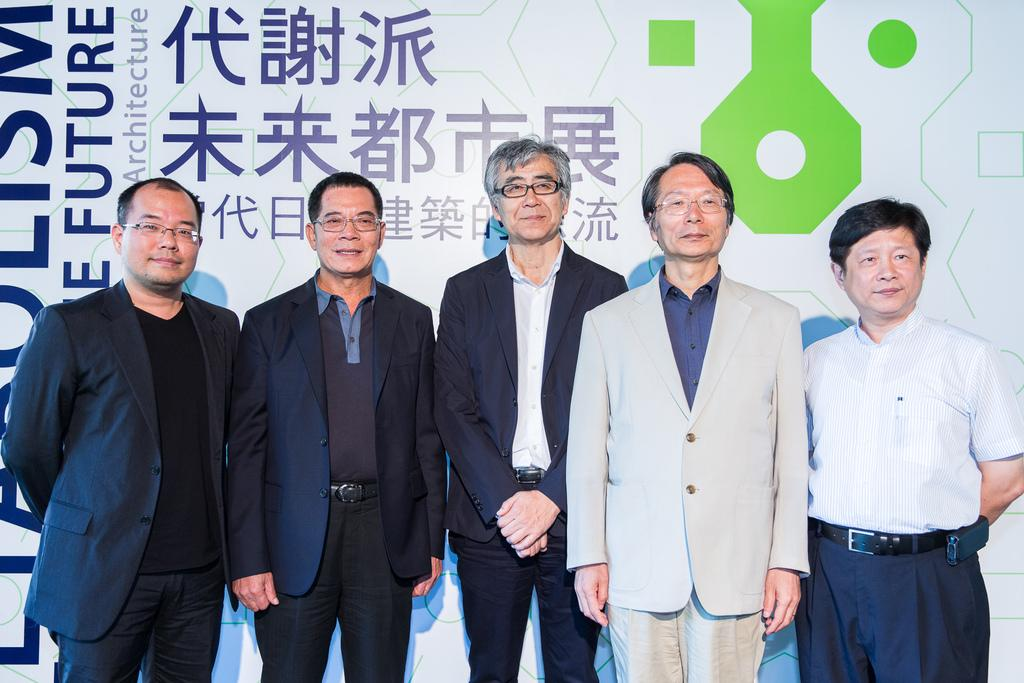What is the main subject of the image? The main subject of the image is people standing in the center. Can you describe the board visible in the background? Unfortunately, the facts provided do not give any details about the board, so we cannot describe it. What type of cracker is being passed around during the feast in the image? There is no feast or cracker present in the image; it only shows people standing in the center and a board visible in the background. 